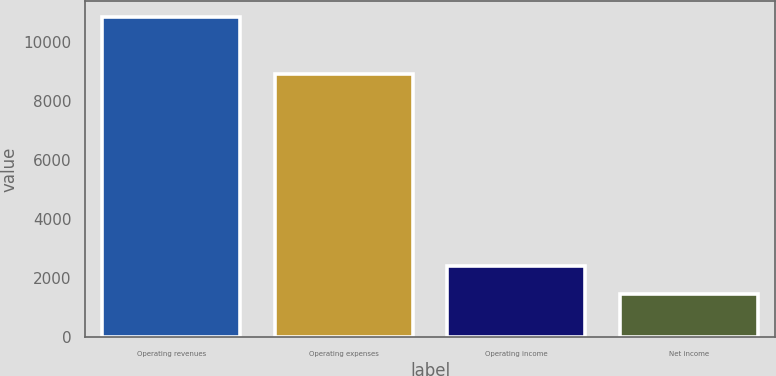Convert chart. <chart><loc_0><loc_0><loc_500><loc_500><bar_chart><fcel>Operating revenues<fcel>Operating expenses<fcel>Operating income<fcel>Net income<nl><fcel>10849<fcel>8928<fcel>2403.4<fcel>1465<nl></chart> 